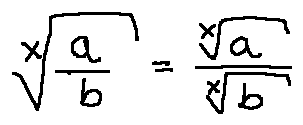Convert formula to latex. <formula><loc_0><loc_0><loc_500><loc_500>\sqrt { [ } x ] { \frac { a } { b } } = \frac { \sqrt { [ } x ] { a } } { \sqrt { [ } x ] { b } }</formula> 